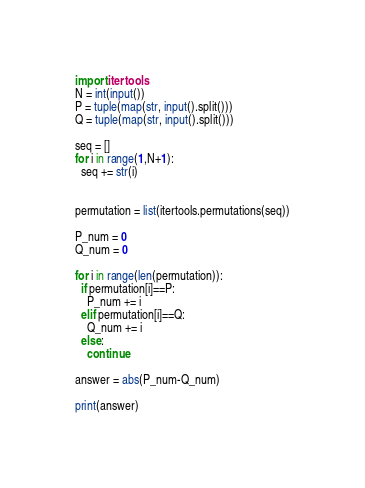<code> <loc_0><loc_0><loc_500><loc_500><_Python_>import itertools
N = int(input())
P = tuple(map(str, input().split()))
Q = tuple(map(str, input().split()))
  
seq = []
for i in range(1,N+1):
  seq += str(i)
  

permutation = list(itertools.permutations(seq))

P_num = 0
Q_num = 0

for i in range(len(permutation)):
  if permutation[i]==P:
    P_num += i
  elif permutation[i]==Q:
    Q_num += i
  else:
    continue
    
answer = abs(P_num-Q_num)

print(answer)</code> 